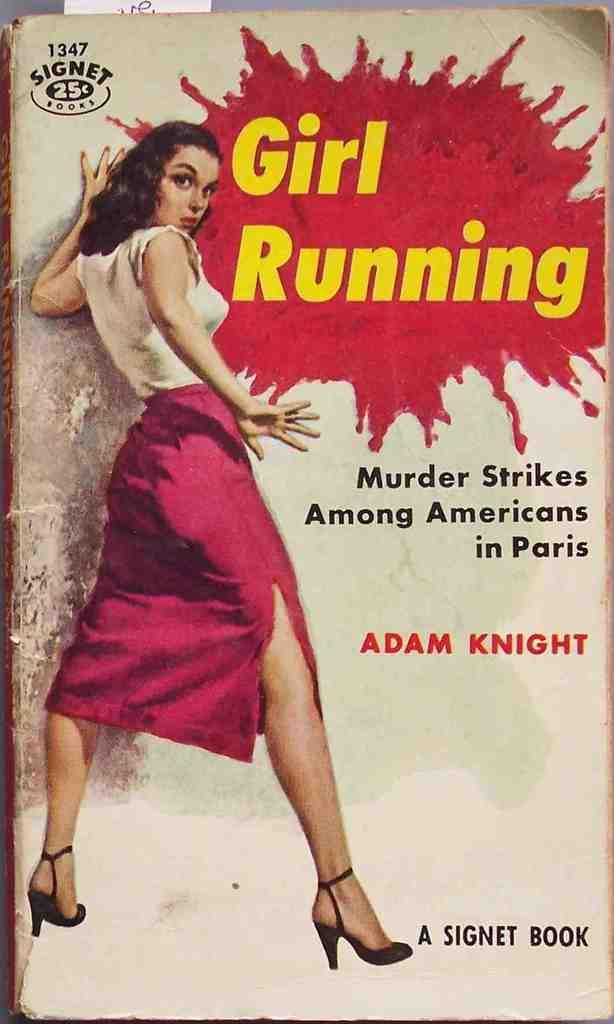Who is the author?
Keep it short and to the point. Adam knight. 